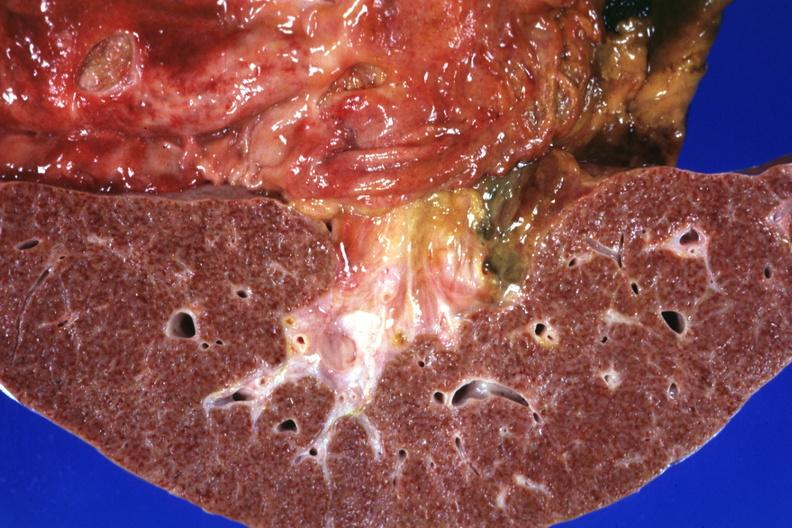what is present?
Answer the question using a single word or phrase. Hepatobiliary 